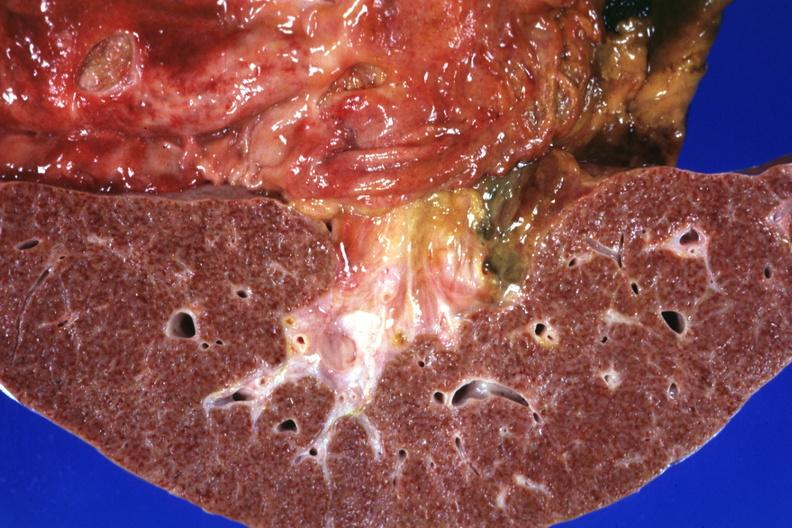what is present?
Answer the question using a single word or phrase. Hepatobiliary 